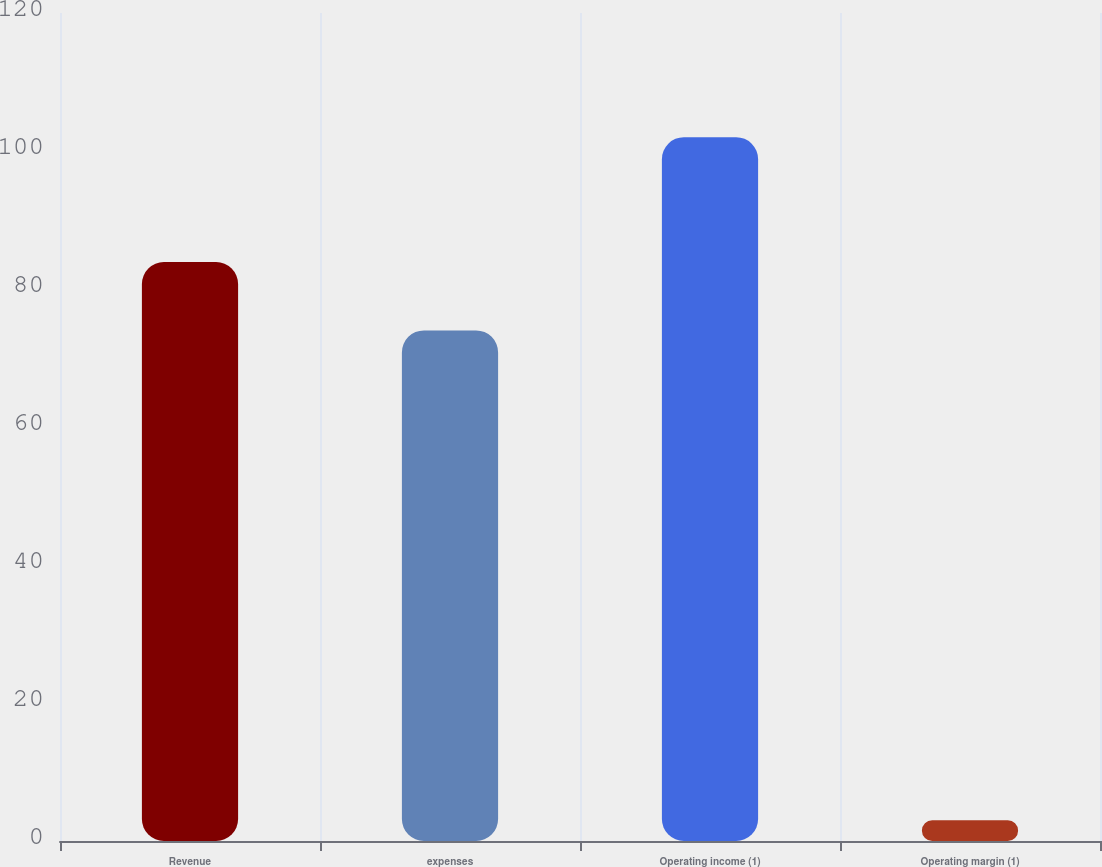<chart> <loc_0><loc_0><loc_500><loc_500><bar_chart><fcel>Revenue<fcel>expenses<fcel>Operating income (1)<fcel>Operating margin (1)<nl><fcel>83.9<fcel>74<fcel>102<fcel>3<nl></chart> 